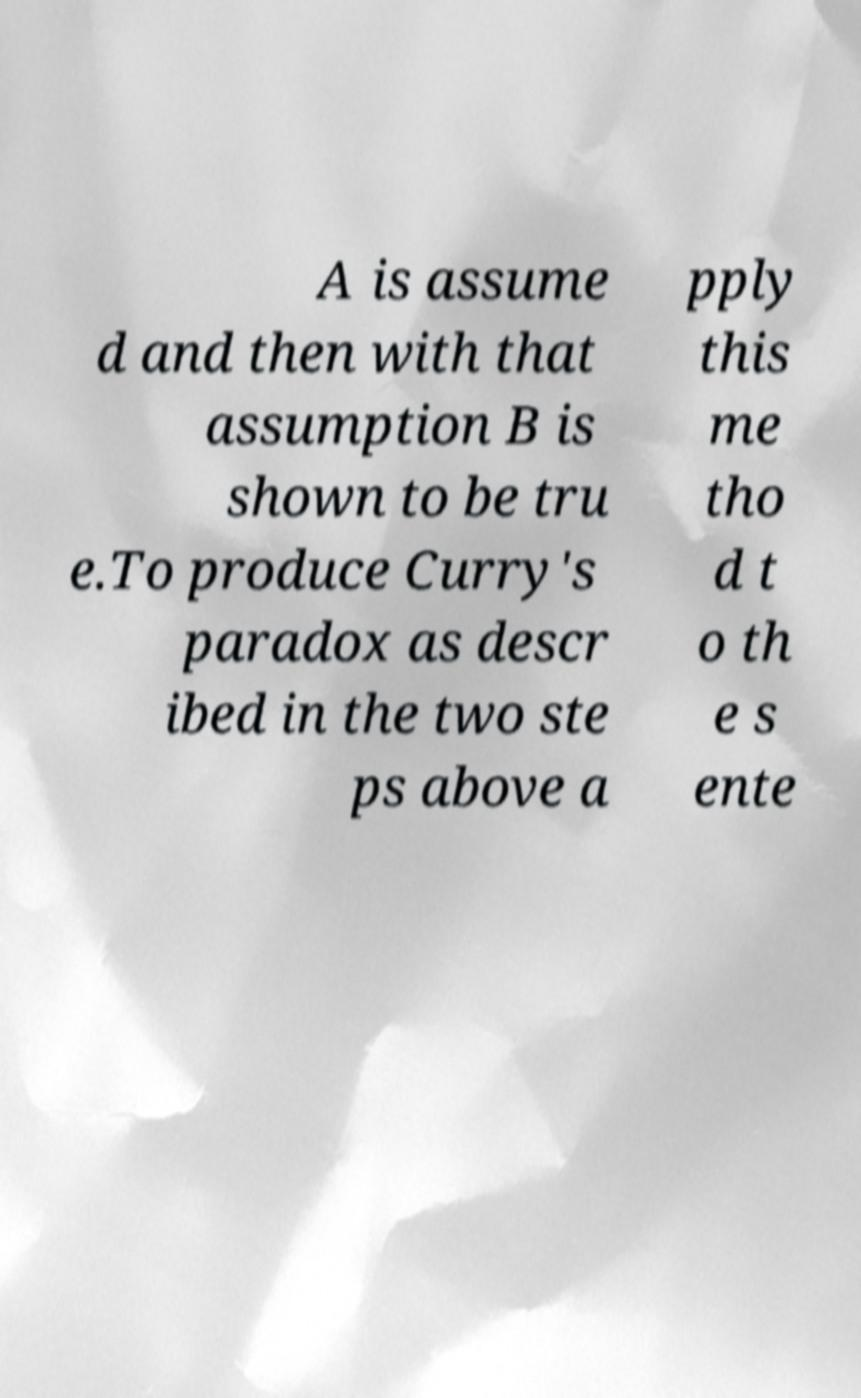There's text embedded in this image that I need extracted. Can you transcribe it verbatim? A is assume d and then with that assumption B is shown to be tru e.To produce Curry's paradox as descr ibed in the two ste ps above a pply this me tho d t o th e s ente 